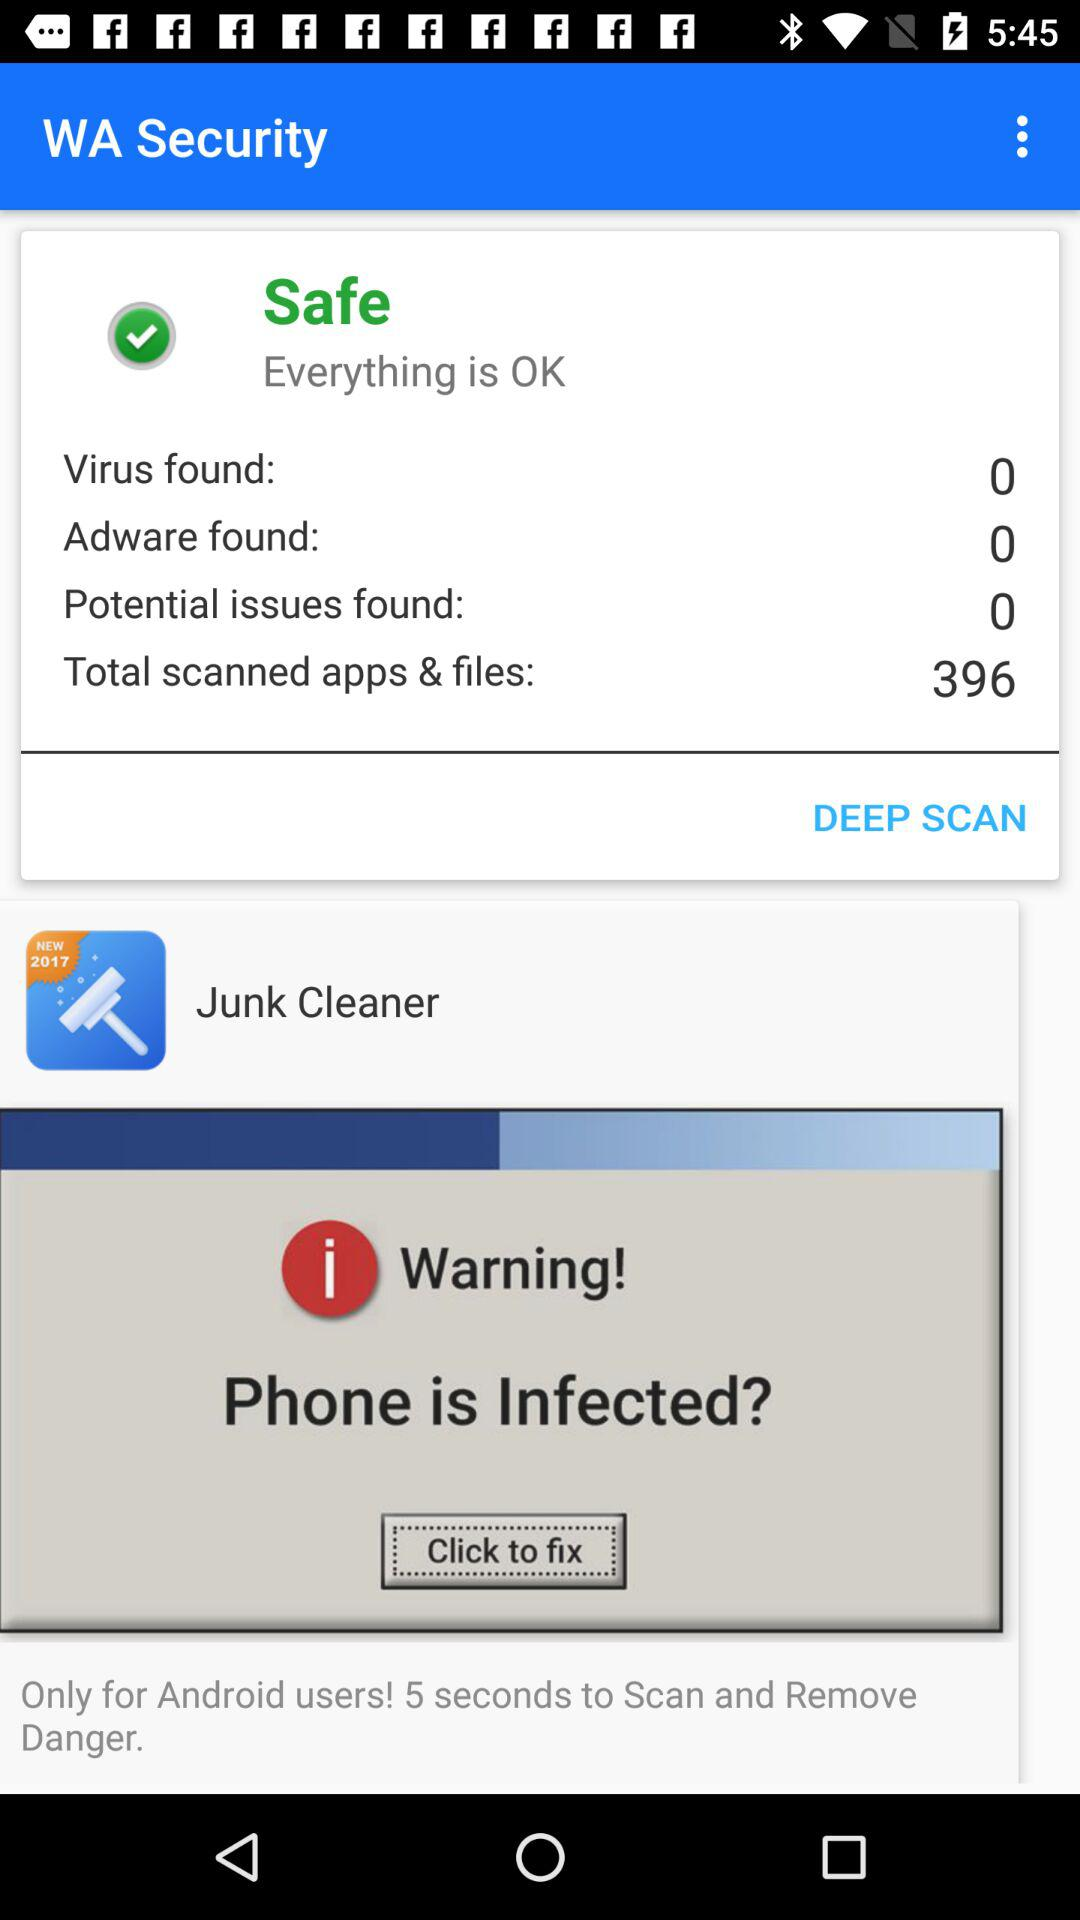How many total scanned apps & files are there? There are a total of 396 scanned apps & files. 